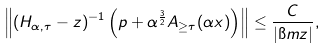Convert formula to latex. <formula><loc_0><loc_0><loc_500><loc_500>\left \| ( H _ { \alpha , \tau } - z ) ^ { - 1 } \left ( p + \alpha ^ { \frac { 3 } { 2 } } A _ { \geq \tau } ( \alpha x ) \right ) \right \| \leq \frac { C } { | \i m z | } ,</formula> 